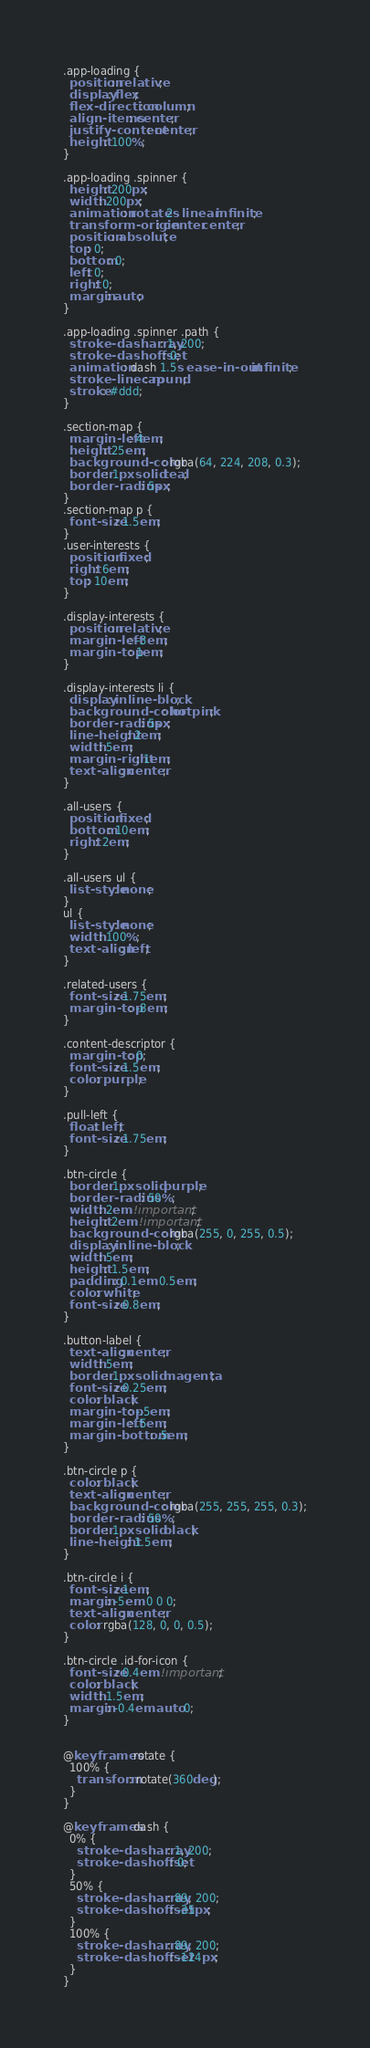<code> <loc_0><loc_0><loc_500><loc_500><_CSS_>.app-loading {
  position: relative;
  display: flex;
  flex-direction: column;
  align-items: center;
  justify-content: center;
  height: 100%;
}

.app-loading .spinner {
  height: 200px;
  width: 200px;
  animation: rotate 2s linear infinite;
  transform-origin: center center;
  position: absolute;
  top: 0;
  bottom: 0;
  left: 0;
  right: 0;
  margin: auto;
}

.app-loading .spinner .path {
  stroke-dasharray: 1, 200;
  stroke-dashoffset: 0;
  animation: dash 1.5s ease-in-out infinite;
  stroke-linecap: round;
  stroke: #ddd;
}

.section-map {
  margin-left: 4em;
  height: 25em;
  background-color: rgba(64, 224, 208, 0.3);
  border: 1px solid teal;
  border-radius: 5px;
}
.section-map p {
  font-size: 1.5em;
}
.user-interests {
  position: fixed; 
  right: 6em;
  top: 10em;
}

.display-interests {
  position: relative;
  margin-left: -3em;
  margin-top: 1em;
}

.display-interests li {
  display: inline-block;
  background-color: hotpink;
  border-radius: 5px;
  line-height: 2em;
  width: 5em;
  margin-right: 1em;
  text-align: center;
}

.all-users {
  position: fixed;
  bottom: 10em;
  right: 2em;
}

.all-users ul {
  list-style: none;
}
ul {
  list-style: none;
  width: 100%;
  text-align: left;
}

.related-users {
  font-size: 1.75em;
  margin-top: -8em;
}

.content-descriptor {
  margin-top: 0;
  font-size: 1.5em;
  color: purple;
}

.pull-left {
  float: left;
  font-size: 1.75em;
}

.btn-circle {
  border: 1px solid purple;
  border-radius: 50%;
  width: 2em !important;
  height: 2em !important;
  background-color: rgba(255, 0, 255, 0.5);
  display: inline-block;
  width: 5em;
  height: 1.5em;
  padding: 0.1em 0.5em;
  color: white;
  font-size: 0.8em;
}

.button-label {
  text-align: center;
  width: 5em;
  border: 1px solid magenta;
  font-size: 0.25em;
  color: black;
  margin-top: -.5em;
  margin-left: .5em;
  margin-bottom: .5em;
}

.btn-circle p {
  color: black;
  text-align: center;
  background-color: rgba(255, 255, 255, 0.3);
  border-radius: 50%;
  border: 1px solid black;
  line-height: 1.5em;
}

.btn-circle i {
  font-size: 1em;
  margin: -5em 0 0 0;
  text-align: center;
  color: rgba(128, 0, 0, 0.5);
}

.btn-circle .id-for-icon {
  font-size: 0.4em !important;
  color: black;
  width: 1.5em;
  margin: -0.4em auto 0;
}


@keyframes rotate {
  100% {
    transform: rotate(360deg);
  }
}

@keyframes dash {
  0% {
    stroke-dasharray: 1, 200;
    stroke-dashoffset: 0;
  }
  50% {
    stroke-dasharray: 89, 200;
    stroke-dashoffset: -35px;
  }
  100% {
    stroke-dasharray: 89, 200;
    stroke-dashoffset: -124px;
  }
}
</code> 